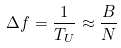Convert formula to latex. <formula><loc_0><loc_0><loc_500><loc_500>\Delta f = \frac { 1 } { T _ { U } } \approx \frac { B } { N }</formula> 